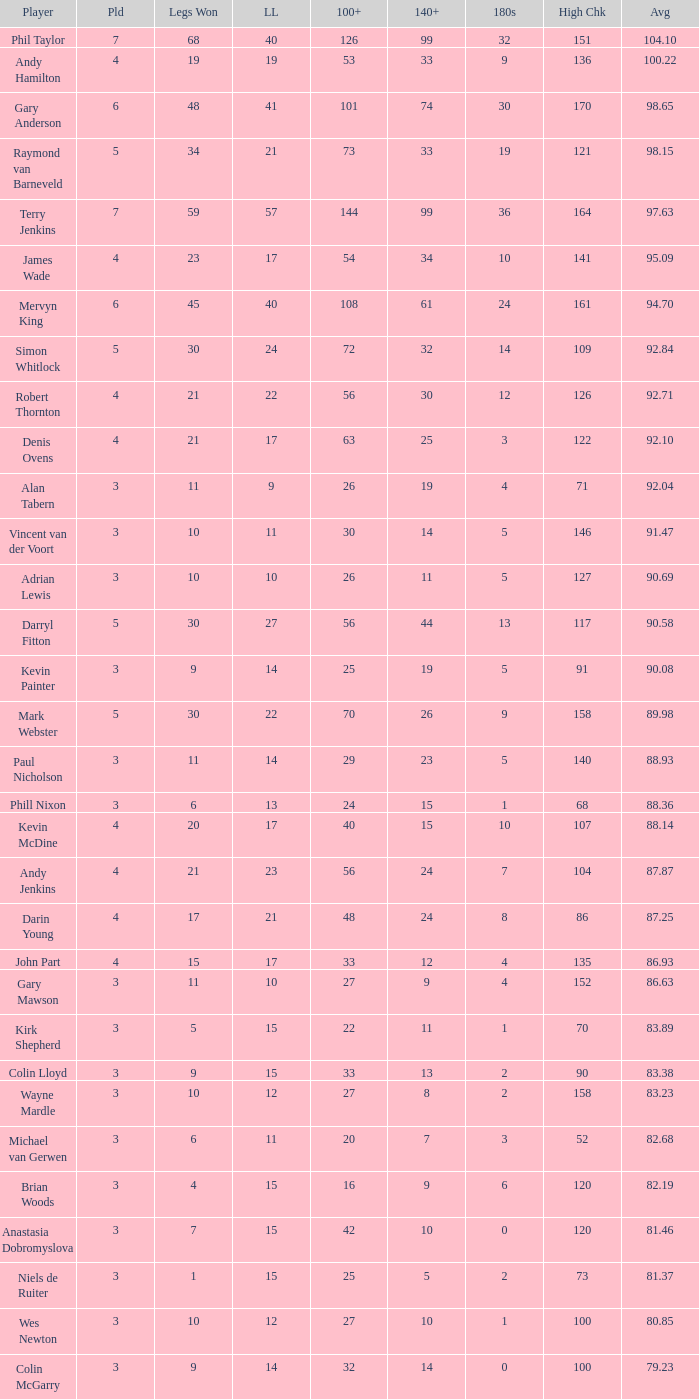What is the total number of 3-dart average when legs lost is larger than 41, and played is larger than 7? 0.0. Parse the table in full. {'header': ['Player', 'Pld', 'Legs Won', 'LL', '100+', '140+', '180s', 'High Chk', 'Avg'], 'rows': [['Phil Taylor', '7', '68', '40', '126', '99', '32', '151', '104.10'], ['Andy Hamilton', '4', '19', '19', '53', '33', '9', '136', '100.22'], ['Gary Anderson', '6', '48', '41', '101', '74', '30', '170', '98.65'], ['Raymond van Barneveld', '5', '34', '21', '73', '33', '19', '121', '98.15'], ['Terry Jenkins', '7', '59', '57', '144', '99', '36', '164', '97.63'], ['James Wade', '4', '23', '17', '54', '34', '10', '141', '95.09'], ['Mervyn King', '6', '45', '40', '108', '61', '24', '161', '94.70'], ['Simon Whitlock', '5', '30', '24', '72', '32', '14', '109', '92.84'], ['Robert Thornton', '4', '21', '22', '56', '30', '12', '126', '92.71'], ['Denis Ovens', '4', '21', '17', '63', '25', '3', '122', '92.10'], ['Alan Tabern', '3', '11', '9', '26', '19', '4', '71', '92.04'], ['Vincent van der Voort', '3', '10', '11', '30', '14', '5', '146', '91.47'], ['Adrian Lewis', '3', '10', '10', '26', '11', '5', '127', '90.69'], ['Darryl Fitton', '5', '30', '27', '56', '44', '13', '117', '90.58'], ['Kevin Painter', '3', '9', '14', '25', '19', '5', '91', '90.08'], ['Mark Webster', '5', '30', '22', '70', '26', '9', '158', '89.98'], ['Paul Nicholson', '3', '11', '14', '29', '23', '5', '140', '88.93'], ['Phill Nixon', '3', '6', '13', '24', '15', '1', '68', '88.36'], ['Kevin McDine', '4', '20', '17', '40', '15', '10', '107', '88.14'], ['Andy Jenkins', '4', '21', '23', '56', '24', '7', '104', '87.87'], ['Darin Young', '4', '17', '21', '48', '24', '8', '86', '87.25'], ['John Part', '4', '15', '17', '33', '12', '4', '135', '86.93'], ['Gary Mawson', '3', '11', '10', '27', '9', '4', '152', '86.63'], ['Kirk Shepherd', '3', '5', '15', '22', '11', '1', '70', '83.89'], ['Colin Lloyd', '3', '9', '15', '33', '13', '2', '90', '83.38'], ['Wayne Mardle', '3', '10', '12', '27', '8', '2', '158', '83.23'], ['Michael van Gerwen', '3', '6', '11', '20', '7', '3', '52', '82.68'], ['Brian Woods', '3', '4', '15', '16', '9', '6', '120', '82.19'], ['Anastasia Dobromyslova', '3', '7', '15', '42', '10', '0', '120', '81.46'], ['Niels de Ruiter', '3', '1', '15', '25', '5', '2', '73', '81.37'], ['Wes Newton', '3', '10', '12', '27', '10', '1', '100', '80.85'], ['Colin McGarry', '3', '9', '14', '32', '14', '0', '100', '79.23']]} 